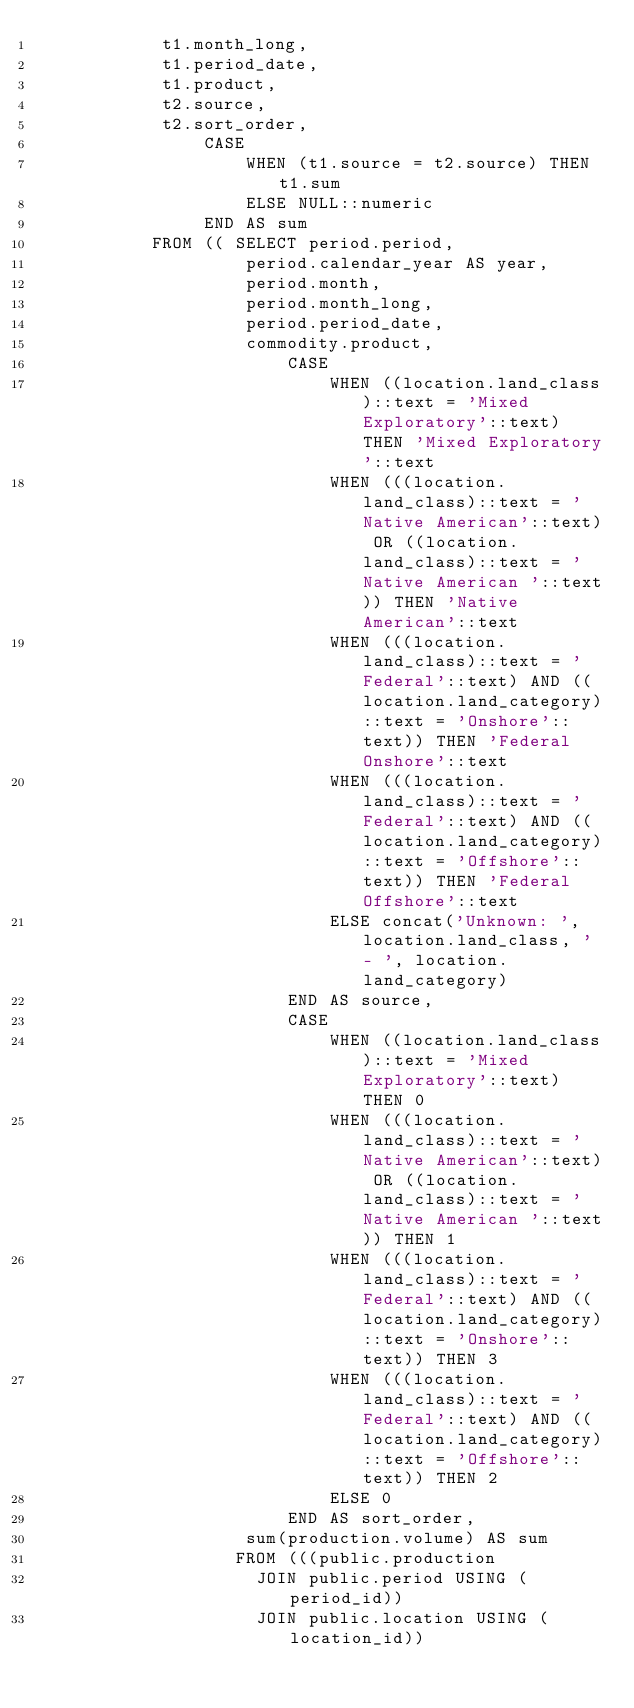Convert code to text. <code><loc_0><loc_0><loc_500><loc_500><_SQL_>            t1.month_long,
            t1.period_date,
            t1.product,
            t2.source,
            t2.sort_order,
                CASE
                    WHEN (t1.source = t2.source) THEN t1.sum
                    ELSE NULL::numeric
                END AS sum
           FROM (( SELECT period.period,
                    period.calendar_year AS year,
                    period.month,
                    period.month_long,
                    period.period_date,
                    commodity.product,
                        CASE
                            WHEN ((location.land_class)::text = 'Mixed Exploratory'::text) THEN 'Mixed Exploratory'::text
                            WHEN (((location.land_class)::text = 'Native American'::text) OR ((location.land_class)::text = 'Native American '::text)) THEN 'Native American'::text
                            WHEN (((location.land_class)::text = 'Federal'::text) AND ((location.land_category)::text = 'Onshore'::text)) THEN 'Federal Onshore'::text
                            WHEN (((location.land_class)::text = 'Federal'::text) AND ((location.land_category)::text = 'Offshore'::text)) THEN 'Federal Offshore'::text
                            ELSE concat('Unknown: ', location.land_class, ' - ', location.land_category)
                        END AS source,
                        CASE
                            WHEN ((location.land_class)::text = 'Mixed Exploratory'::text) THEN 0
                            WHEN (((location.land_class)::text = 'Native American'::text) OR ((location.land_class)::text = 'Native American '::text)) THEN 1
                            WHEN (((location.land_class)::text = 'Federal'::text) AND ((location.land_category)::text = 'Onshore'::text)) THEN 3
                            WHEN (((location.land_class)::text = 'Federal'::text) AND ((location.land_category)::text = 'Offshore'::text)) THEN 2
                            ELSE 0
                        END AS sort_order,
                    sum(production.volume) AS sum
                   FROM (((public.production
                     JOIN public.period USING (period_id))
                     JOIN public.location USING (location_id))</code> 